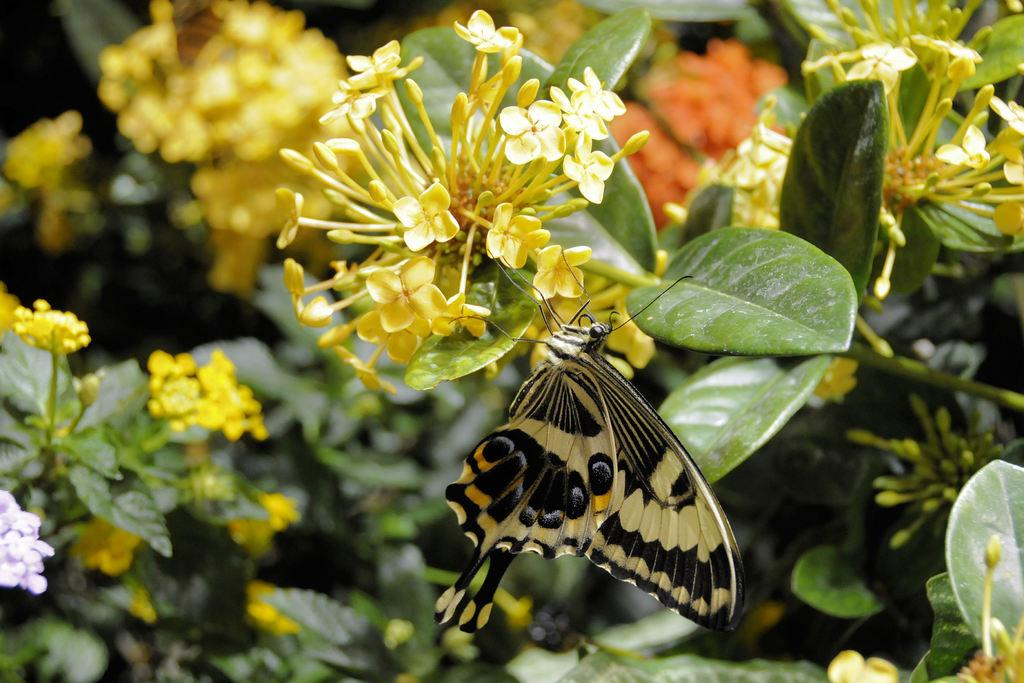What type of insect is present in the image? There is a black butterfly in the image. What are the main features of the butterfly? The butterfly has wings. What other object can be seen in the image? There is a plant in the image. What is the color of the flowers on the plant? The flowers on the plant are yellow. What type of box can be seen holding the scent of the butterfly in the image? There is no box or scent associated with the butterflies in the image; it simply features a black butterfly and a plant with yellow flowers. 